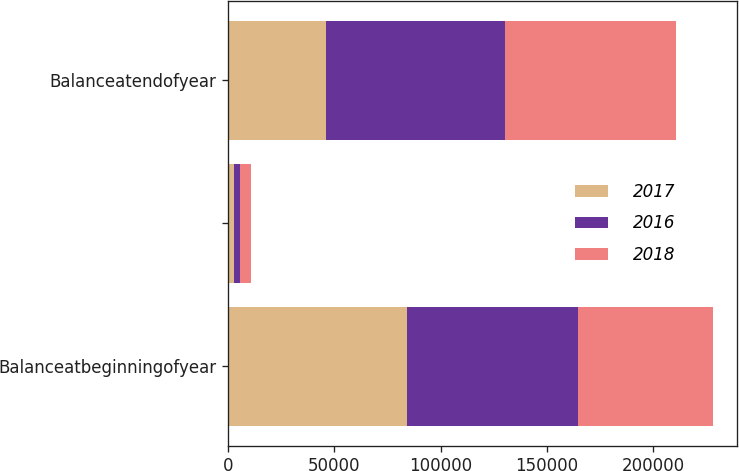<chart> <loc_0><loc_0><loc_500><loc_500><stacked_bar_chart><ecel><fcel>Balanceatbeginningofyear<fcel>Unnamed: 2<fcel>Balanceatendofyear<nl><fcel>2017<fcel>84244<fcel>2752<fcel>46074<nl><fcel>2016<fcel>80388<fcel>2690<fcel>84244<nl><fcel>2018<fcel>63549<fcel>5278<fcel>80388<nl></chart> 